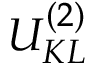<formula> <loc_0><loc_0><loc_500><loc_500>{ U } _ { K L } ^ { ( 2 ) }</formula> 